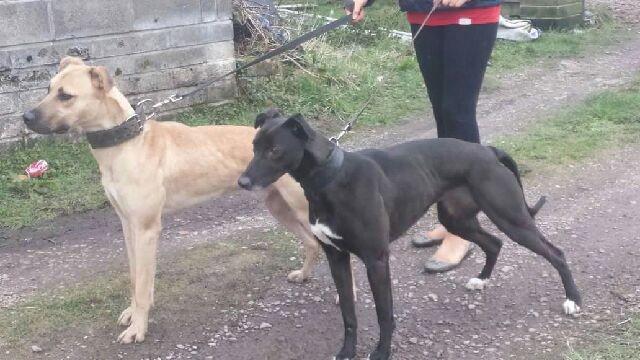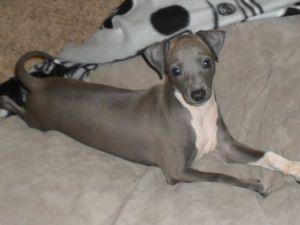The first image is the image on the left, the second image is the image on the right. Analyze the images presented: Is the assertion "Left image contains two standing dogs, and right image contains one non-standing dog." valid? Answer yes or no. Yes. The first image is the image on the left, the second image is the image on the right. Given the left and right images, does the statement "There are three dogs shown." hold true? Answer yes or no. Yes. 